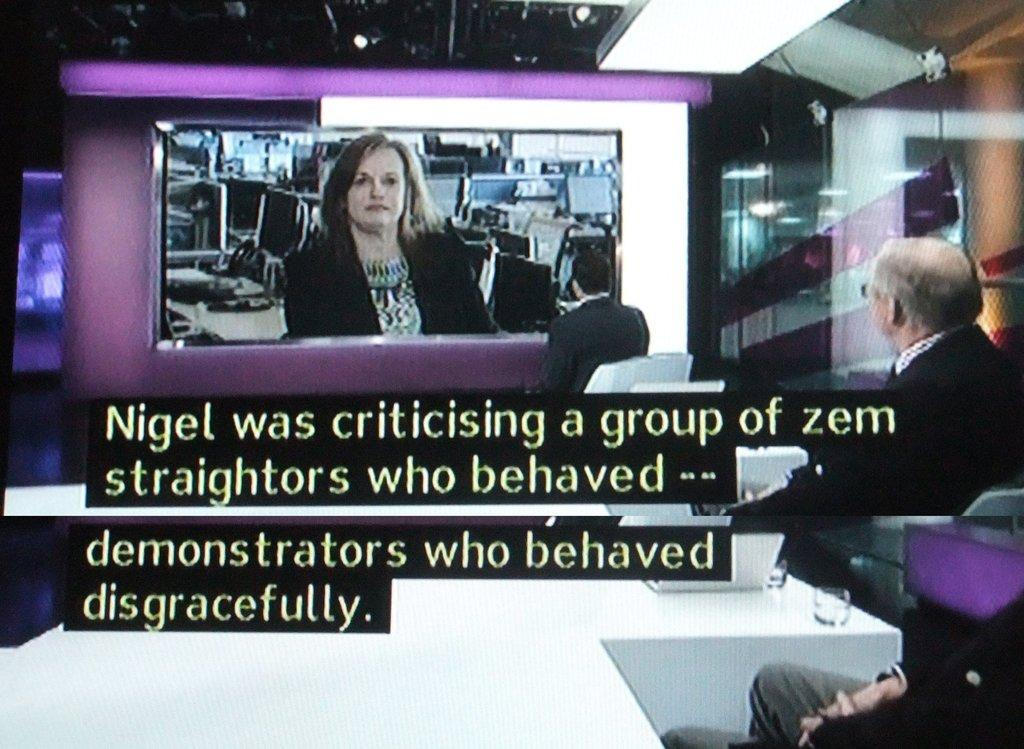<image>
Share a concise interpretation of the image provided. A presentation that says Nigel was criticising a group of zem straightors. 